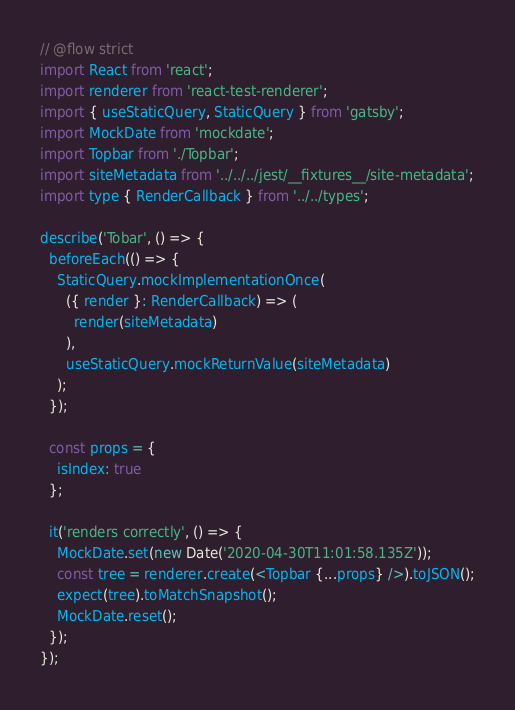Convert code to text. <code><loc_0><loc_0><loc_500><loc_500><_JavaScript_>// @flow strict
import React from 'react';
import renderer from 'react-test-renderer';
import { useStaticQuery, StaticQuery } from 'gatsby';
import MockDate from 'mockdate';
import Topbar from './Topbar';
import siteMetadata from '../../../jest/__fixtures__/site-metadata';
import type { RenderCallback } from '../../types';

describe('Tobar', () => {
  beforeEach(() => {
    StaticQuery.mockImplementationOnce(
      ({ render }: RenderCallback) => (
        render(siteMetadata)
      ),
      useStaticQuery.mockReturnValue(siteMetadata)
    );
  });

  const props = {
    isIndex: true
  };

  it('renders correctly', () => {
    MockDate.set(new Date('2020-04-30T11:01:58.135Z'));
    const tree = renderer.create(<Topbar {...props} />).toJSON();
    expect(tree).toMatchSnapshot();
    MockDate.reset();
  });
});
</code> 